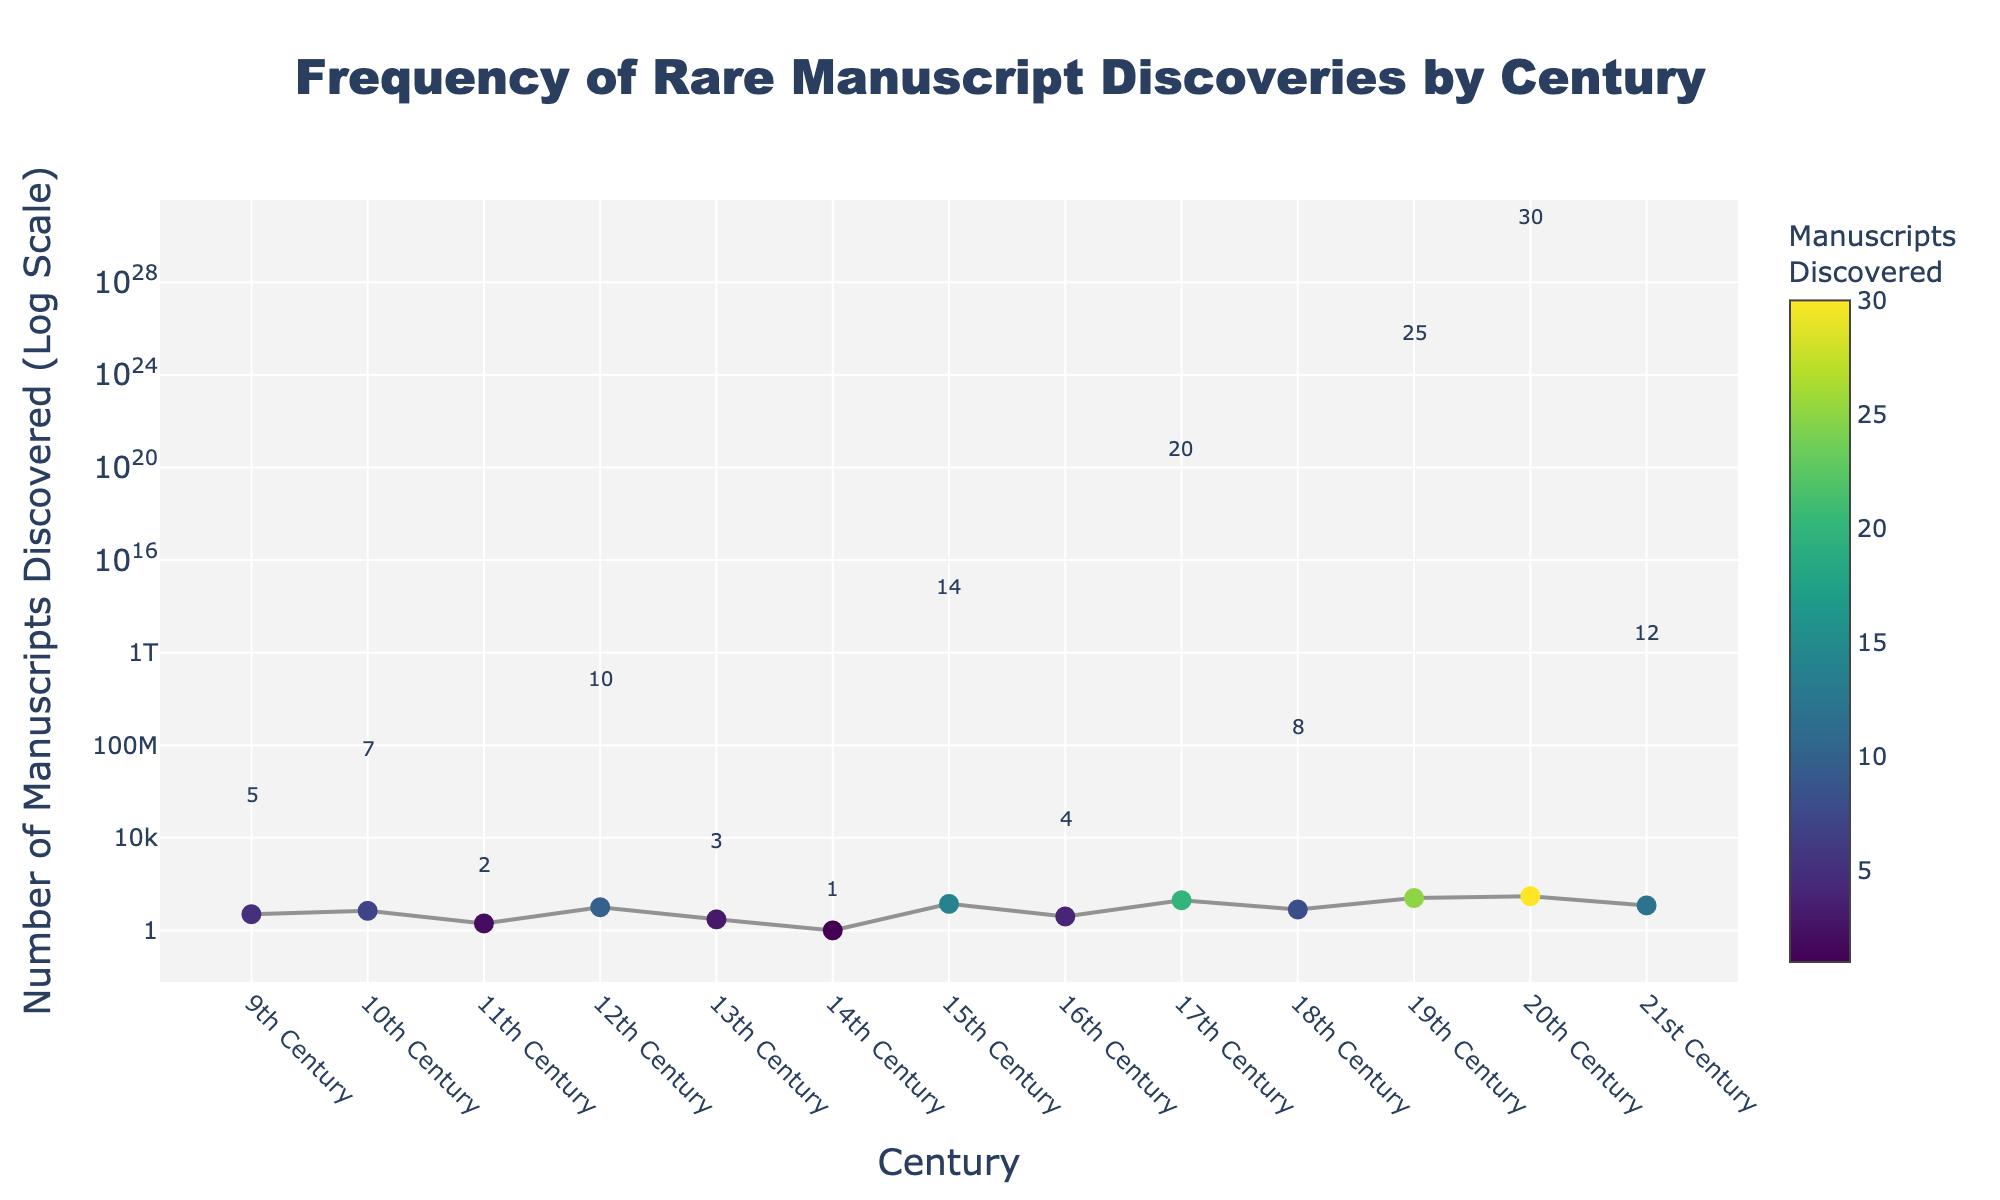What is the title of the plot? The title of the plot is displayed prominently at the top of the figure in large and bold text. It reads "Frequency of Rare Manuscript Discoveries by Century".
Answer: Frequency of Rare Manuscript Discoveries by Century How many manuscripts were discovered in the 20th century? The annotation above the data point for the 20th Century shows the number of manuscripts discovered during that period.
Answer: 30 What is the smallest number of manuscripts discovered in any given century shown in the graph? The smallest number of manuscripts discovered, marked by the lowest data point, is annotated near the 14th Century. The annotation shows that it is 1.
Answer: 1 Which century saw the highest number of manuscript discoveries? By examining the data points and annotations above them, the 20th Century has the highest annotation number of 30.
Answer: 20th Century What is the change in the number of manuscripts discovered from the 18th to the 19th century? From the annotations, the 18th Century has 8 manuscripts discovered, and the 19th Century has 25. The change is calculated as 25 - 8.
Answer: 17 How many centuries have a discovery rate of more than 10 manuscripts? The annotations above each point show that the 12th Century (10), 15th Century (14), 17th Century (20), 19th Century (25), 20th Century (30), and 21st Century (12) have discovery rates more than 10. There are 6 such centuries.
Answer: 6 In which century do we see the largest drop in manuscript discoveries compared to the previous century? Analyzing the drops between consecutive centuries, the largest drop is from the 10th Century (7 manuscripts) to the 11th Century (2 manuscripts), showing a decrease of 5.
Answer: 11th Century What is the average number of manuscripts discovered in the 9th, 10th, and 11th centuries? The average (mean) is found by summing the numbers (5, 7, 2) and dividing by the count (3). So, (5+7+2)/3 = 14/3.
Answer: 4.67 What is the median number of manuscripts discovered for all centuries shown? Ordering the values: 1, 2, 3, 4, 5, 7, 8, 10, 12, 14, 20, 25, 30. The middle value in this odd-numbered set (13 values) is 8.
Answer: 8 Why is a logarithmic scale used for the y-axis in this plot? A logarithmic scale is useful when the data spans several orders of magnitude, as it allows smaller values and larger values to be compared on the same scale. Here, manuscript discoveries range from 1 to 30. A linear scale would make it difficult to visualize and interpret the lower values while a log scale compresses the differences proportionally.
Answer: To show wide range of values effectively 